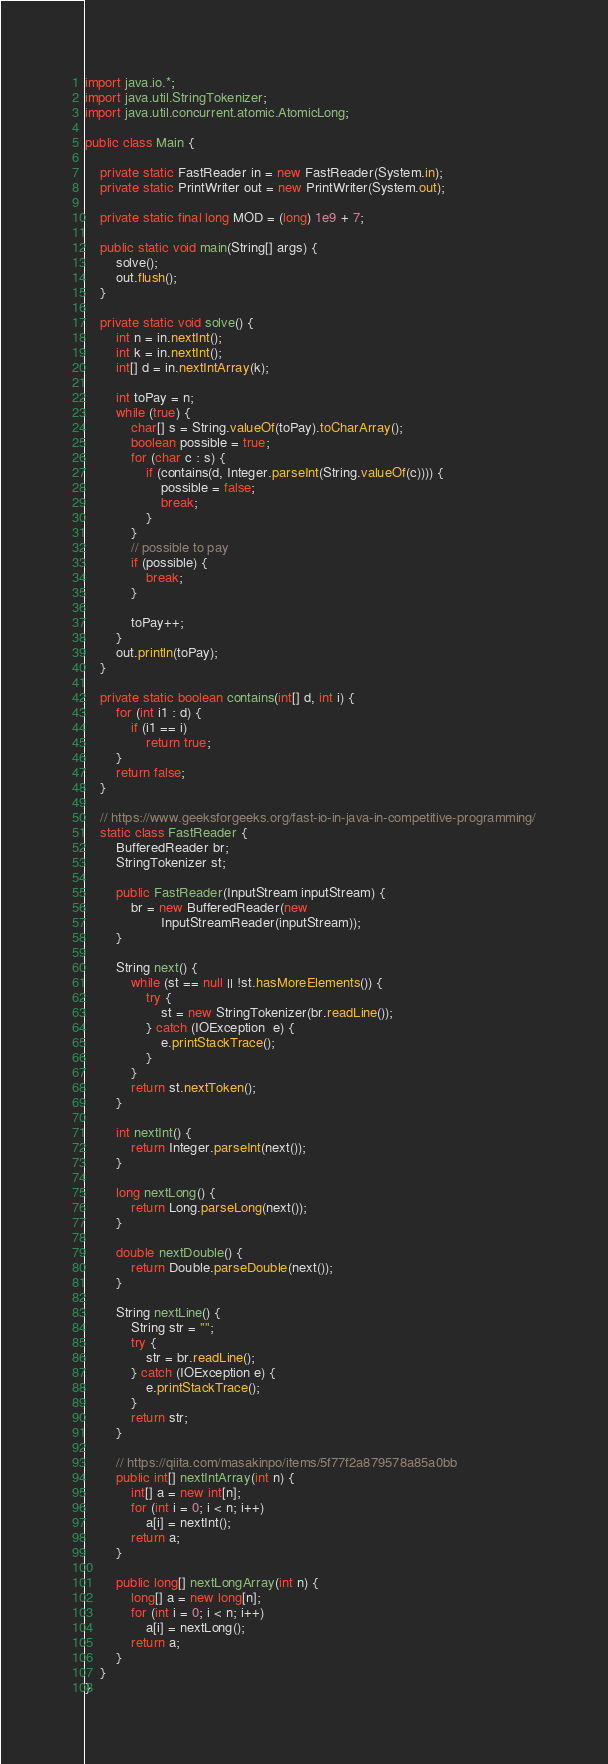<code> <loc_0><loc_0><loc_500><loc_500><_Java_>import java.io.*;
import java.util.StringTokenizer;
import java.util.concurrent.atomic.AtomicLong;

public class Main {

    private static FastReader in = new FastReader(System.in);
    private static PrintWriter out = new PrintWriter(System.out);

    private static final long MOD = (long) 1e9 + 7;

    public static void main(String[] args) {
        solve();
        out.flush();
    }

    private static void solve() {
        int n = in.nextInt();
        int k = in.nextInt();
        int[] d = in.nextIntArray(k);

        int toPay = n;
        while (true) {
            char[] s = String.valueOf(toPay).toCharArray();
            boolean possible = true;
            for (char c : s) {
                if (contains(d, Integer.parseInt(String.valueOf(c)))) {
                    possible = false;
                    break;
                }
            }
            // possible to pay
            if (possible) {
                break;
            }

            toPay++;
        }
        out.println(toPay);
    }

    private static boolean contains(int[] d, int i) {
        for (int i1 : d) {
            if (i1 == i)
                return true;
        }
        return false;
    }

    // https://www.geeksforgeeks.org/fast-io-in-java-in-competitive-programming/
    static class FastReader {
        BufferedReader br;
        StringTokenizer st;

        public FastReader(InputStream inputStream) {
            br = new BufferedReader(new
                    InputStreamReader(inputStream));
        }

        String next() {
            while (st == null || !st.hasMoreElements()) {
                try {
                    st = new StringTokenizer(br.readLine());
                } catch (IOException  e) {
                    e.printStackTrace();
                }
            }
            return st.nextToken();
        }

        int nextInt() {
            return Integer.parseInt(next());
        }

        long nextLong() {
            return Long.parseLong(next());
        }

        double nextDouble() {
            return Double.parseDouble(next());
        }

        String nextLine() {
            String str = "";
            try {
                str = br.readLine();
            } catch (IOException e) {
                e.printStackTrace();
            }
            return str;
        }

        // https://qiita.com/masakinpo/items/5f77f2a879578a85a0bb
        public int[] nextIntArray(int n) {
            int[] a = new int[n];
            for (int i = 0; i < n; i++)
                a[i] = nextInt();
            return a;
        }

        public long[] nextLongArray(int n) {
            long[] a = new long[n];
            for (int i = 0; i < n; i++)
                a[i] = nextLong();
            return a;
        }
    }
}
</code> 